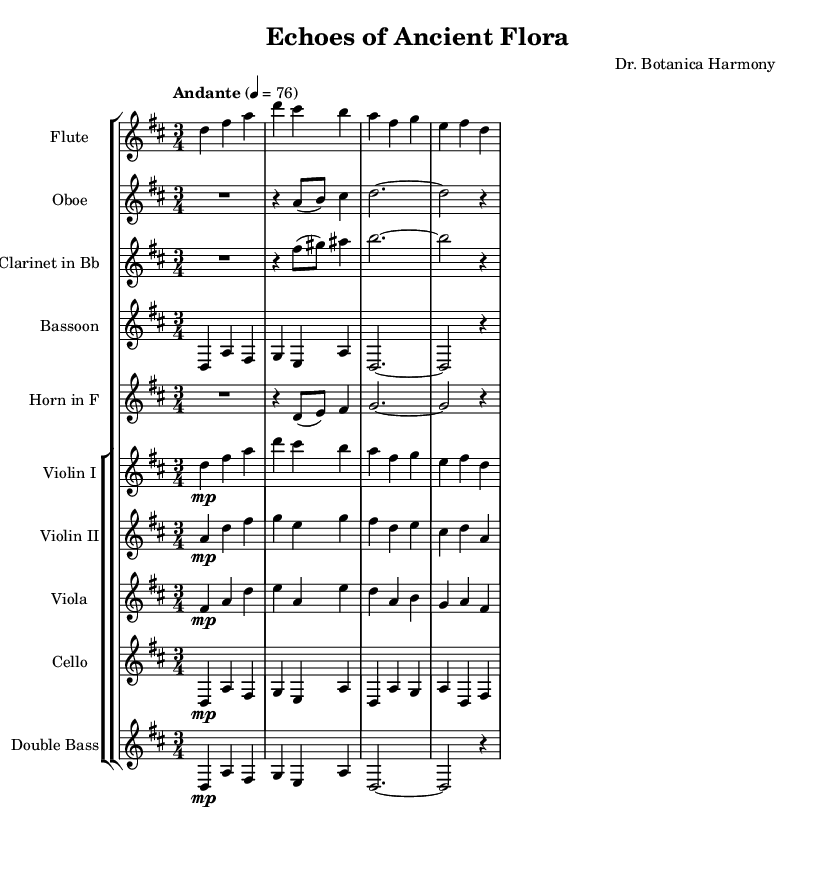What is the key signature of this music? The key signature is indicated by the sharp symbols at the beginning of the staff. In this case, it has two sharps, which corresponds to the key of D major.
Answer: D major What is the time signature of this music? The time signature is shown after the key signature at the beginning of the score. Here, it shows a 3 over 4, indicating that there are three beats in a measure and the quarter note gets one beat.
Answer: 3/4 What is the tempo marking for this piece? The tempo marking is indicated by the text below the staff. In this case, it specifies "Andante" at a metronome marking of 4 = 76, meaning a moderate pace.
Answer: Andante How many instruments are featured in this score? This score features a total of 10 instruments, as seen in the staff groups listed, including woodwinds, brass, and strings.
Answer: 10 Which woodwind instruments are included in this piece? According to the staves in the score, the woodwind instruments present are the flute, oboe, clarinet, and bassoon. These can be identified by their respective staves at the beginning of the score.
Answer: Flute, Oboe, Clarinet, Bassoon What is the dynamic marking for the violin parts? The dynamic marking for the violin parts is indicated by the letters “mp” preceding the notes, which stands for "mezzo-piano," indicating a moderately soft volume. This means that both violin I and II have this marking.
Answer: mp What does the use of rests in the score signify? The rests in the score indicate moments of silence for each instrument, specifically where the musicians do not play. This creates a texture that adds to the musical expression of the symphonic suite, particularly in the oboe and clarinet parts.
Answer: Silence 